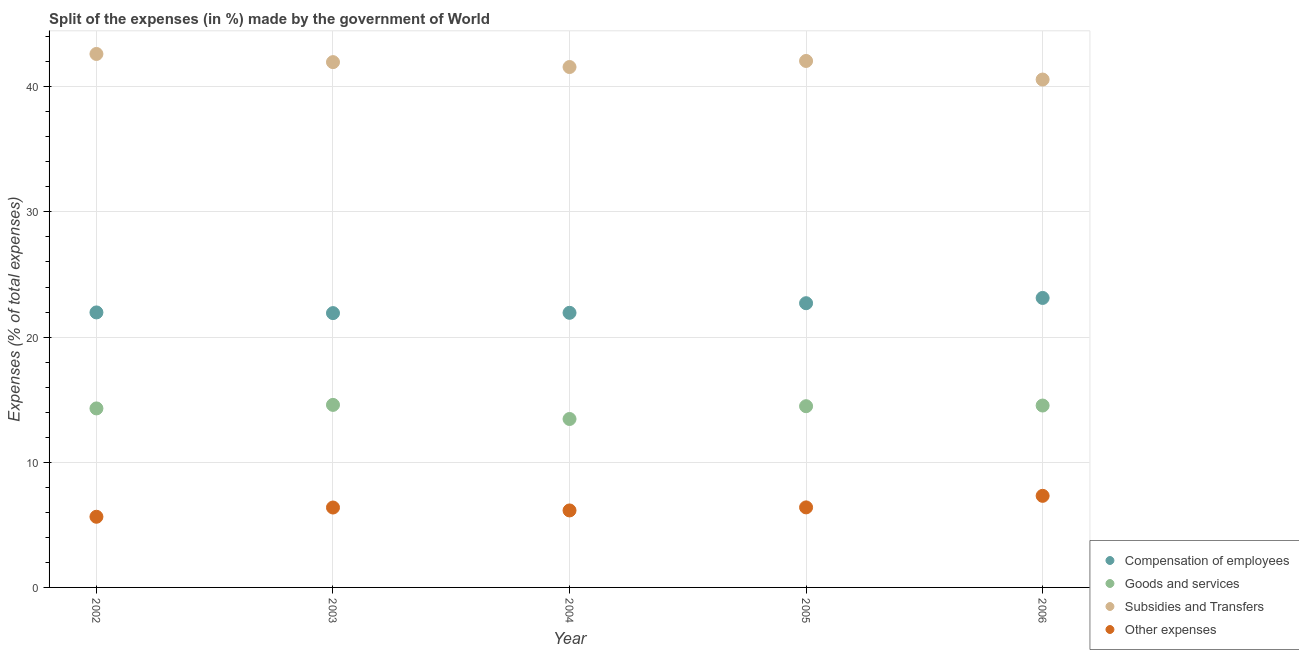How many different coloured dotlines are there?
Your answer should be compact. 4. What is the percentage of amount spent on other expenses in 2002?
Make the answer very short. 5.65. Across all years, what is the maximum percentage of amount spent on compensation of employees?
Your response must be concise. 23.13. Across all years, what is the minimum percentage of amount spent on subsidies?
Provide a short and direct response. 40.58. In which year was the percentage of amount spent on goods and services maximum?
Make the answer very short. 2003. In which year was the percentage of amount spent on other expenses minimum?
Your answer should be very brief. 2002. What is the total percentage of amount spent on goods and services in the graph?
Your answer should be compact. 71.35. What is the difference between the percentage of amount spent on goods and services in 2002 and that in 2004?
Ensure brevity in your answer.  0.84. What is the difference between the percentage of amount spent on compensation of employees in 2006 and the percentage of amount spent on goods and services in 2004?
Provide a short and direct response. 9.67. What is the average percentage of amount spent on compensation of employees per year?
Keep it short and to the point. 22.33. In the year 2006, what is the difference between the percentage of amount spent on compensation of employees and percentage of amount spent on goods and services?
Keep it short and to the point. 8.6. In how many years, is the percentage of amount spent on goods and services greater than 16 %?
Your answer should be very brief. 0. What is the ratio of the percentage of amount spent on compensation of employees in 2002 to that in 2005?
Ensure brevity in your answer.  0.97. Is the difference between the percentage of amount spent on other expenses in 2003 and 2006 greater than the difference between the percentage of amount spent on goods and services in 2003 and 2006?
Your response must be concise. No. What is the difference between the highest and the second highest percentage of amount spent on compensation of employees?
Give a very brief answer. 0.42. What is the difference between the highest and the lowest percentage of amount spent on other expenses?
Your answer should be very brief. 1.67. In how many years, is the percentage of amount spent on compensation of employees greater than the average percentage of amount spent on compensation of employees taken over all years?
Offer a very short reply. 2. Is the sum of the percentage of amount spent on subsidies in 2005 and 2006 greater than the maximum percentage of amount spent on other expenses across all years?
Offer a terse response. Yes. Is it the case that in every year, the sum of the percentage of amount spent on compensation of employees and percentage of amount spent on goods and services is greater than the percentage of amount spent on subsidies?
Offer a terse response. No. Is the percentage of amount spent on other expenses strictly greater than the percentage of amount spent on compensation of employees over the years?
Provide a succinct answer. No. Is the percentage of amount spent on goods and services strictly less than the percentage of amount spent on other expenses over the years?
Your response must be concise. No. How many dotlines are there?
Offer a terse response. 4. How many years are there in the graph?
Ensure brevity in your answer.  5. Are the values on the major ticks of Y-axis written in scientific E-notation?
Offer a very short reply. No. How many legend labels are there?
Offer a very short reply. 4. What is the title of the graph?
Provide a succinct answer. Split of the expenses (in %) made by the government of World. Does "Finland" appear as one of the legend labels in the graph?
Your answer should be compact. No. What is the label or title of the X-axis?
Your response must be concise. Year. What is the label or title of the Y-axis?
Keep it short and to the point. Expenses (% of total expenses). What is the Expenses (% of total expenses) of Compensation of employees in 2002?
Ensure brevity in your answer.  21.97. What is the Expenses (% of total expenses) in Goods and services in 2002?
Ensure brevity in your answer.  14.3. What is the Expenses (% of total expenses) of Subsidies and Transfers in 2002?
Your answer should be very brief. 42.62. What is the Expenses (% of total expenses) in Other expenses in 2002?
Your response must be concise. 5.65. What is the Expenses (% of total expenses) of Compensation of employees in 2003?
Give a very brief answer. 21.92. What is the Expenses (% of total expenses) in Goods and services in 2003?
Your answer should be very brief. 14.58. What is the Expenses (% of total expenses) of Subsidies and Transfers in 2003?
Offer a very short reply. 41.97. What is the Expenses (% of total expenses) of Other expenses in 2003?
Ensure brevity in your answer.  6.38. What is the Expenses (% of total expenses) of Compensation of employees in 2004?
Make the answer very short. 21.94. What is the Expenses (% of total expenses) in Goods and services in 2004?
Ensure brevity in your answer.  13.46. What is the Expenses (% of total expenses) of Subsidies and Transfers in 2004?
Give a very brief answer. 41.58. What is the Expenses (% of total expenses) of Other expenses in 2004?
Provide a short and direct response. 6.15. What is the Expenses (% of total expenses) of Compensation of employees in 2005?
Offer a terse response. 22.71. What is the Expenses (% of total expenses) of Goods and services in 2005?
Make the answer very short. 14.48. What is the Expenses (% of total expenses) in Subsidies and Transfers in 2005?
Your answer should be compact. 42.06. What is the Expenses (% of total expenses) of Other expenses in 2005?
Keep it short and to the point. 6.39. What is the Expenses (% of total expenses) of Compensation of employees in 2006?
Make the answer very short. 23.13. What is the Expenses (% of total expenses) of Goods and services in 2006?
Ensure brevity in your answer.  14.53. What is the Expenses (% of total expenses) of Subsidies and Transfers in 2006?
Offer a very short reply. 40.58. What is the Expenses (% of total expenses) of Other expenses in 2006?
Offer a terse response. 7.32. Across all years, what is the maximum Expenses (% of total expenses) of Compensation of employees?
Provide a succinct answer. 23.13. Across all years, what is the maximum Expenses (% of total expenses) of Goods and services?
Make the answer very short. 14.58. Across all years, what is the maximum Expenses (% of total expenses) in Subsidies and Transfers?
Your response must be concise. 42.62. Across all years, what is the maximum Expenses (% of total expenses) of Other expenses?
Make the answer very short. 7.32. Across all years, what is the minimum Expenses (% of total expenses) in Compensation of employees?
Provide a short and direct response. 21.92. Across all years, what is the minimum Expenses (% of total expenses) of Goods and services?
Provide a short and direct response. 13.46. Across all years, what is the minimum Expenses (% of total expenses) in Subsidies and Transfers?
Keep it short and to the point. 40.58. Across all years, what is the minimum Expenses (% of total expenses) of Other expenses?
Provide a succinct answer. 5.65. What is the total Expenses (% of total expenses) of Compensation of employees in the graph?
Keep it short and to the point. 111.66. What is the total Expenses (% of total expenses) of Goods and services in the graph?
Offer a terse response. 71.35. What is the total Expenses (% of total expenses) of Subsidies and Transfers in the graph?
Keep it short and to the point. 208.8. What is the total Expenses (% of total expenses) of Other expenses in the graph?
Provide a short and direct response. 31.89. What is the difference between the Expenses (% of total expenses) of Compensation of employees in 2002 and that in 2003?
Keep it short and to the point. 0.06. What is the difference between the Expenses (% of total expenses) of Goods and services in 2002 and that in 2003?
Ensure brevity in your answer.  -0.28. What is the difference between the Expenses (% of total expenses) of Subsidies and Transfers in 2002 and that in 2003?
Provide a succinct answer. 0.65. What is the difference between the Expenses (% of total expenses) of Other expenses in 2002 and that in 2003?
Keep it short and to the point. -0.74. What is the difference between the Expenses (% of total expenses) in Compensation of employees in 2002 and that in 2004?
Offer a very short reply. 0.03. What is the difference between the Expenses (% of total expenses) of Goods and services in 2002 and that in 2004?
Provide a short and direct response. 0.84. What is the difference between the Expenses (% of total expenses) in Subsidies and Transfers in 2002 and that in 2004?
Your answer should be very brief. 1.04. What is the difference between the Expenses (% of total expenses) of Other expenses in 2002 and that in 2004?
Offer a very short reply. -0.51. What is the difference between the Expenses (% of total expenses) in Compensation of employees in 2002 and that in 2005?
Provide a short and direct response. -0.74. What is the difference between the Expenses (% of total expenses) in Goods and services in 2002 and that in 2005?
Offer a very short reply. -0.18. What is the difference between the Expenses (% of total expenses) of Subsidies and Transfers in 2002 and that in 2005?
Offer a very short reply. 0.56. What is the difference between the Expenses (% of total expenses) in Other expenses in 2002 and that in 2005?
Keep it short and to the point. -0.75. What is the difference between the Expenses (% of total expenses) of Compensation of employees in 2002 and that in 2006?
Your response must be concise. -1.16. What is the difference between the Expenses (% of total expenses) in Goods and services in 2002 and that in 2006?
Your response must be concise. -0.23. What is the difference between the Expenses (% of total expenses) in Subsidies and Transfers in 2002 and that in 2006?
Keep it short and to the point. 2.04. What is the difference between the Expenses (% of total expenses) of Other expenses in 2002 and that in 2006?
Provide a short and direct response. -1.67. What is the difference between the Expenses (% of total expenses) in Compensation of employees in 2003 and that in 2004?
Ensure brevity in your answer.  -0.02. What is the difference between the Expenses (% of total expenses) of Goods and services in 2003 and that in 2004?
Your answer should be very brief. 1.13. What is the difference between the Expenses (% of total expenses) in Subsidies and Transfers in 2003 and that in 2004?
Keep it short and to the point. 0.39. What is the difference between the Expenses (% of total expenses) in Other expenses in 2003 and that in 2004?
Your answer should be very brief. 0.23. What is the difference between the Expenses (% of total expenses) of Compensation of employees in 2003 and that in 2005?
Offer a terse response. -0.79. What is the difference between the Expenses (% of total expenses) in Goods and services in 2003 and that in 2005?
Provide a short and direct response. 0.1. What is the difference between the Expenses (% of total expenses) of Subsidies and Transfers in 2003 and that in 2005?
Give a very brief answer. -0.09. What is the difference between the Expenses (% of total expenses) of Other expenses in 2003 and that in 2005?
Provide a succinct answer. -0.01. What is the difference between the Expenses (% of total expenses) of Compensation of employees in 2003 and that in 2006?
Provide a short and direct response. -1.21. What is the difference between the Expenses (% of total expenses) in Goods and services in 2003 and that in 2006?
Your answer should be very brief. 0.05. What is the difference between the Expenses (% of total expenses) of Subsidies and Transfers in 2003 and that in 2006?
Provide a short and direct response. 1.39. What is the difference between the Expenses (% of total expenses) of Other expenses in 2003 and that in 2006?
Offer a very short reply. -0.93. What is the difference between the Expenses (% of total expenses) in Compensation of employees in 2004 and that in 2005?
Offer a terse response. -0.77. What is the difference between the Expenses (% of total expenses) of Goods and services in 2004 and that in 2005?
Ensure brevity in your answer.  -1.02. What is the difference between the Expenses (% of total expenses) in Subsidies and Transfers in 2004 and that in 2005?
Provide a short and direct response. -0.48. What is the difference between the Expenses (% of total expenses) in Other expenses in 2004 and that in 2005?
Your answer should be very brief. -0.24. What is the difference between the Expenses (% of total expenses) in Compensation of employees in 2004 and that in 2006?
Offer a terse response. -1.19. What is the difference between the Expenses (% of total expenses) in Goods and services in 2004 and that in 2006?
Offer a very short reply. -1.07. What is the difference between the Expenses (% of total expenses) of Other expenses in 2004 and that in 2006?
Offer a very short reply. -1.17. What is the difference between the Expenses (% of total expenses) of Compensation of employees in 2005 and that in 2006?
Provide a short and direct response. -0.42. What is the difference between the Expenses (% of total expenses) of Goods and services in 2005 and that in 2006?
Make the answer very short. -0.05. What is the difference between the Expenses (% of total expenses) of Subsidies and Transfers in 2005 and that in 2006?
Keep it short and to the point. 1.48. What is the difference between the Expenses (% of total expenses) of Other expenses in 2005 and that in 2006?
Make the answer very short. -0.92. What is the difference between the Expenses (% of total expenses) of Compensation of employees in 2002 and the Expenses (% of total expenses) of Goods and services in 2003?
Offer a very short reply. 7.39. What is the difference between the Expenses (% of total expenses) in Compensation of employees in 2002 and the Expenses (% of total expenses) in Subsidies and Transfers in 2003?
Give a very brief answer. -20. What is the difference between the Expenses (% of total expenses) of Compensation of employees in 2002 and the Expenses (% of total expenses) of Other expenses in 2003?
Provide a succinct answer. 15.59. What is the difference between the Expenses (% of total expenses) of Goods and services in 2002 and the Expenses (% of total expenses) of Subsidies and Transfers in 2003?
Keep it short and to the point. -27.67. What is the difference between the Expenses (% of total expenses) of Goods and services in 2002 and the Expenses (% of total expenses) of Other expenses in 2003?
Your answer should be very brief. 7.92. What is the difference between the Expenses (% of total expenses) in Subsidies and Transfers in 2002 and the Expenses (% of total expenses) in Other expenses in 2003?
Keep it short and to the point. 36.24. What is the difference between the Expenses (% of total expenses) of Compensation of employees in 2002 and the Expenses (% of total expenses) of Goods and services in 2004?
Offer a terse response. 8.51. What is the difference between the Expenses (% of total expenses) in Compensation of employees in 2002 and the Expenses (% of total expenses) in Subsidies and Transfers in 2004?
Provide a short and direct response. -19.61. What is the difference between the Expenses (% of total expenses) of Compensation of employees in 2002 and the Expenses (% of total expenses) of Other expenses in 2004?
Provide a short and direct response. 15.82. What is the difference between the Expenses (% of total expenses) in Goods and services in 2002 and the Expenses (% of total expenses) in Subsidies and Transfers in 2004?
Your response must be concise. -27.28. What is the difference between the Expenses (% of total expenses) in Goods and services in 2002 and the Expenses (% of total expenses) in Other expenses in 2004?
Your response must be concise. 8.15. What is the difference between the Expenses (% of total expenses) of Subsidies and Transfers in 2002 and the Expenses (% of total expenses) of Other expenses in 2004?
Provide a short and direct response. 36.47. What is the difference between the Expenses (% of total expenses) in Compensation of employees in 2002 and the Expenses (% of total expenses) in Goods and services in 2005?
Your answer should be compact. 7.49. What is the difference between the Expenses (% of total expenses) of Compensation of employees in 2002 and the Expenses (% of total expenses) of Subsidies and Transfers in 2005?
Your answer should be very brief. -20.09. What is the difference between the Expenses (% of total expenses) in Compensation of employees in 2002 and the Expenses (% of total expenses) in Other expenses in 2005?
Make the answer very short. 15.58. What is the difference between the Expenses (% of total expenses) of Goods and services in 2002 and the Expenses (% of total expenses) of Subsidies and Transfers in 2005?
Your answer should be very brief. -27.76. What is the difference between the Expenses (% of total expenses) of Goods and services in 2002 and the Expenses (% of total expenses) of Other expenses in 2005?
Make the answer very short. 7.91. What is the difference between the Expenses (% of total expenses) in Subsidies and Transfers in 2002 and the Expenses (% of total expenses) in Other expenses in 2005?
Make the answer very short. 36.23. What is the difference between the Expenses (% of total expenses) of Compensation of employees in 2002 and the Expenses (% of total expenses) of Goods and services in 2006?
Make the answer very short. 7.44. What is the difference between the Expenses (% of total expenses) in Compensation of employees in 2002 and the Expenses (% of total expenses) in Subsidies and Transfers in 2006?
Your answer should be compact. -18.61. What is the difference between the Expenses (% of total expenses) in Compensation of employees in 2002 and the Expenses (% of total expenses) in Other expenses in 2006?
Provide a succinct answer. 14.65. What is the difference between the Expenses (% of total expenses) in Goods and services in 2002 and the Expenses (% of total expenses) in Subsidies and Transfers in 2006?
Offer a terse response. -26.28. What is the difference between the Expenses (% of total expenses) of Goods and services in 2002 and the Expenses (% of total expenses) of Other expenses in 2006?
Provide a succinct answer. 6.98. What is the difference between the Expenses (% of total expenses) of Subsidies and Transfers in 2002 and the Expenses (% of total expenses) of Other expenses in 2006?
Provide a succinct answer. 35.3. What is the difference between the Expenses (% of total expenses) in Compensation of employees in 2003 and the Expenses (% of total expenses) in Goods and services in 2004?
Keep it short and to the point. 8.46. What is the difference between the Expenses (% of total expenses) of Compensation of employees in 2003 and the Expenses (% of total expenses) of Subsidies and Transfers in 2004?
Make the answer very short. -19.66. What is the difference between the Expenses (% of total expenses) of Compensation of employees in 2003 and the Expenses (% of total expenses) of Other expenses in 2004?
Provide a succinct answer. 15.77. What is the difference between the Expenses (% of total expenses) of Goods and services in 2003 and the Expenses (% of total expenses) of Subsidies and Transfers in 2004?
Provide a succinct answer. -26.99. What is the difference between the Expenses (% of total expenses) of Goods and services in 2003 and the Expenses (% of total expenses) of Other expenses in 2004?
Ensure brevity in your answer.  8.43. What is the difference between the Expenses (% of total expenses) of Subsidies and Transfers in 2003 and the Expenses (% of total expenses) of Other expenses in 2004?
Make the answer very short. 35.82. What is the difference between the Expenses (% of total expenses) in Compensation of employees in 2003 and the Expenses (% of total expenses) in Goods and services in 2005?
Make the answer very short. 7.44. What is the difference between the Expenses (% of total expenses) in Compensation of employees in 2003 and the Expenses (% of total expenses) in Subsidies and Transfers in 2005?
Ensure brevity in your answer.  -20.15. What is the difference between the Expenses (% of total expenses) in Compensation of employees in 2003 and the Expenses (% of total expenses) in Other expenses in 2005?
Ensure brevity in your answer.  15.52. What is the difference between the Expenses (% of total expenses) in Goods and services in 2003 and the Expenses (% of total expenses) in Subsidies and Transfers in 2005?
Keep it short and to the point. -27.48. What is the difference between the Expenses (% of total expenses) of Goods and services in 2003 and the Expenses (% of total expenses) of Other expenses in 2005?
Your response must be concise. 8.19. What is the difference between the Expenses (% of total expenses) of Subsidies and Transfers in 2003 and the Expenses (% of total expenses) of Other expenses in 2005?
Keep it short and to the point. 35.57. What is the difference between the Expenses (% of total expenses) of Compensation of employees in 2003 and the Expenses (% of total expenses) of Goods and services in 2006?
Provide a short and direct response. 7.38. What is the difference between the Expenses (% of total expenses) of Compensation of employees in 2003 and the Expenses (% of total expenses) of Subsidies and Transfers in 2006?
Offer a very short reply. -18.66. What is the difference between the Expenses (% of total expenses) in Compensation of employees in 2003 and the Expenses (% of total expenses) in Other expenses in 2006?
Keep it short and to the point. 14.6. What is the difference between the Expenses (% of total expenses) in Goods and services in 2003 and the Expenses (% of total expenses) in Subsidies and Transfers in 2006?
Ensure brevity in your answer.  -25.99. What is the difference between the Expenses (% of total expenses) in Goods and services in 2003 and the Expenses (% of total expenses) in Other expenses in 2006?
Your answer should be very brief. 7.27. What is the difference between the Expenses (% of total expenses) of Subsidies and Transfers in 2003 and the Expenses (% of total expenses) of Other expenses in 2006?
Your response must be concise. 34.65. What is the difference between the Expenses (% of total expenses) in Compensation of employees in 2004 and the Expenses (% of total expenses) in Goods and services in 2005?
Offer a very short reply. 7.46. What is the difference between the Expenses (% of total expenses) in Compensation of employees in 2004 and the Expenses (% of total expenses) in Subsidies and Transfers in 2005?
Your response must be concise. -20.12. What is the difference between the Expenses (% of total expenses) of Compensation of employees in 2004 and the Expenses (% of total expenses) of Other expenses in 2005?
Your answer should be compact. 15.55. What is the difference between the Expenses (% of total expenses) in Goods and services in 2004 and the Expenses (% of total expenses) in Subsidies and Transfers in 2005?
Ensure brevity in your answer.  -28.6. What is the difference between the Expenses (% of total expenses) of Goods and services in 2004 and the Expenses (% of total expenses) of Other expenses in 2005?
Make the answer very short. 7.06. What is the difference between the Expenses (% of total expenses) in Subsidies and Transfers in 2004 and the Expenses (% of total expenses) in Other expenses in 2005?
Provide a short and direct response. 35.18. What is the difference between the Expenses (% of total expenses) of Compensation of employees in 2004 and the Expenses (% of total expenses) of Goods and services in 2006?
Keep it short and to the point. 7.41. What is the difference between the Expenses (% of total expenses) of Compensation of employees in 2004 and the Expenses (% of total expenses) of Subsidies and Transfers in 2006?
Your response must be concise. -18.64. What is the difference between the Expenses (% of total expenses) in Compensation of employees in 2004 and the Expenses (% of total expenses) in Other expenses in 2006?
Offer a very short reply. 14.62. What is the difference between the Expenses (% of total expenses) in Goods and services in 2004 and the Expenses (% of total expenses) in Subsidies and Transfers in 2006?
Keep it short and to the point. -27.12. What is the difference between the Expenses (% of total expenses) in Goods and services in 2004 and the Expenses (% of total expenses) in Other expenses in 2006?
Keep it short and to the point. 6.14. What is the difference between the Expenses (% of total expenses) of Subsidies and Transfers in 2004 and the Expenses (% of total expenses) of Other expenses in 2006?
Keep it short and to the point. 34.26. What is the difference between the Expenses (% of total expenses) in Compensation of employees in 2005 and the Expenses (% of total expenses) in Goods and services in 2006?
Keep it short and to the point. 8.18. What is the difference between the Expenses (% of total expenses) of Compensation of employees in 2005 and the Expenses (% of total expenses) of Subsidies and Transfers in 2006?
Ensure brevity in your answer.  -17.87. What is the difference between the Expenses (% of total expenses) of Compensation of employees in 2005 and the Expenses (% of total expenses) of Other expenses in 2006?
Your answer should be very brief. 15.39. What is the difference between the Expenses (% of total expenses) of Goods and services in 2005 and the Expenses (% of total expenses) of Subsidies and Transfers in 2006?
Offer a terse response. -26.1. What is the difference between the Expenses (% of total expenses) of Goods and services in 2005 and the Expenses (% of total expenses) of Other expenses in 2006?
Ensure brevity in your answer.  7.16. What is the difference between the Expenses (% of total expenses) of Subsidies and Transfers in 2005 and the Expenses (% of total expenses) of Other expenses in 2006?
Make the answer very short. 34.74. What is the average Expenses (% of total expenses) of Compensation of employees per year?
Your response must be concise. 22.33. What is the average Expenses (% of total expenses) of Goods and services per year?
Offer a terse response. 14.27. What is the average Expenses (% of total expenses) of Subsidies and Transfers per year?
Make the answer very short. 41.76. What is the average Expenses (% of total expenses) in Other expenses per year?
Ensure brevity in your answer.  6.38. In the year 2002, what is the difference between the Expenses (% of total expenses) of Compensation of employees and Expenses (% of total expenses) of Goods and services?
Ensure brevity in your answer.  7.67. In the year 2002, what is the difference between the Expenses (% of total expenses) in Compensation of employees and Expenses (% of total expenses) in Subsidies and Transfers?
Offer a very short reply. -20.65. In the year 2002, what is the difference between the Expenses (% of total expenses) in Compensation of employees and Expenses (% of total expenses) in Other expenses?
Offer a terse response. 16.33. In the year 2002, what is the difference between the Expenses (% of total expenses) in Goods and services and Expenses (% of total expenses) in Subsidies and Transfers?
Offer a terse response. -28.32. In the year 2002, what is the difference between the Expenses (% of total expenses) of Goods and services and Expenses (% of total expenses) of Other expenses?
Offer a terse response. 8.66. In the year 2002, what is the difference between the Expenses (% of total expenses) of Subsidies and Transfers and Expenses (% of total expenses) of Other expenses?
Offer a terse response. 36.98. In the year 2003, what is the difference between the Expenses (% of total expenses) in Compensation of employees and Expenses (% of total expenses) in Goods and services?
Offer a terse response. 7.33. In the year 2003, what is the difference between the Expenses (% of total expenses) in Compensation of employees and Expenses (% of total expenses) in Subsidies and Transfers?
Keep it short and to the point. -20.05. In the year 2003, what is the difference between the Expenses (% of total expenses) in Compensation of employees and Expenses (% of total expenses) in Other expenses?
Provide a short and direct response. 15.53. In the year 2003, what is the difference between the Expenses (% of total expenses) of Goods and services and Expenses (% of total expenses) of Subsidies and Transfers?
Provide a succinct answer. -27.39. In the year 2003, what is the difference between the Expenses (% of total expenses) in Goods and services and Expenses (% of total expenses) in Other expenses?
Provide a succinct answer. 8.2. In the year 2003, what is the difference between the Expenses (% of total expenses) in Subsidies and Transfers and Expenses (% of total expenses) in Other expenses?
Offer a very short reply. 35.58. In the year 2004, what is the difference between the Expenses (% of total expenses) in Compensation of employees and Expenses (% of total expenses) in Goods and services?
Offer a very short reply. 8.48. In the year 2004, what is the difference between the Expenses (% of total expenses) of Compensation of employees and Expenses (% of total expenses) of Subsidies and Transfers?
Your answer should be compact. -19.64. In the year 2004, what is the difference between the Expenses (% of total expenses) of Compensation of employees and Expenses (% of total expenses) of Other expenses?
Offer a terse response. 15.79. In the year 2004, what is the difference between the Expenses (% of total expenses) in Goods and services and Expenses (% of total expenses) in Subsidies and Transfers?
Ensure brevity in your answer.  -28.12. In the year 2004, what is the difference between the Expenses (% of total expenses) in Goods and services and Expenses (% of total expenses) in Other expenses?
Give a very brief answer. 7.31. In the year 2004, what is the difference between the Expenses (% of total expenses) in Subsidies and Transfers and Expenses (% of total expenses) in Other expenses?
Your answer should be very brief. 35.43. In the year 2005, what is the difference between the Expenses (% of total expenses) in Compensation of employees and Expenses (% of total expenses) in Goods and services?
Provide a short and direct response. 8.23. In the year 2005, what is the difference between the Expenses (% of total expenses) in Compensation of employees and Expenses (% of total expenses) in Subsidies and Transfers?
Ensure brevity in your answer.  -19.35. In the year 2005, what is the difference between the Expenses (% of total expenses) of Compensation of employees and Expenses (% of total expenses) of Other expenses?
Make the answer very short. 16.31. In the year 2005, what is the difference between the Expenses (% of total expenses) in Goods and services and Expenses (% of total expenses) in Subsidies and Transfers?
Offer a very short reply. -27.58. In the year 2005, what is the difference between the Expenses (% of total expenses) of Goods and services and Expenses (% of total expenses) of Other expenses?
Offer a terse response. 8.08. In the year 2005, what is the difference between the Expenses (% of total expenses) of Subsidies and Transfers and Expenses (% of total expenses) of Other expenses?
Offer a very short reply. 35.67. In the year 2006, what is the difference between the Expenses (% of total expenses) of Compensation of employees and Expenses (% of total expenses) of Goods and services?
Make the answer very short. 8.6. In the year 2006, what is the difference between the Expenses (% of total expenses) in Compensation of employees and Expenses (% of total expenses) in Subsidies and Transfers?
Make the answer very short. -17.45. In the year 2006, what is the difference between the Expenses (% of total expenses) in Compensation of employees and Expenses (% of total expenses) in Other expenses?
Your answer should be very brief. 15.81. In the year 2006, what is the difference between the Expenses (% of total expenses) of Goods and services and Expenses (% of total expenses) of Subsidies and Transfers?
Keep it short and to the point. -26.05. In the year 2006, what is the difference between the Expenses (% of total expenses) of Goods and services and Expenses (% of total expenses) of Other expenses?
Provide a succinct answer. 7.21. In the year 2006, what is the difference between the Expenses (% of total expenses) of Subsidies and Transfers and Expenses (% of total expenses) of Other expenses?
Provide a short and direct response. 33.26. What is the ratio of the Expenses (% of total expenses) in Goods and services in 2002 to that in 2003?
Offer a very short reply. 0.98. What is the ratio of the Expenses (% of total expenses) in Subsidies and Transfers in 2002 to that in 2003?
Your answer should be compact. 1.02. What is the ratio of the Expenses (% of total expenses) in Other expenses in 2002 to that in 2003?
Your answer should be very brief. 0.88. What is the ratio of the Expenses (% of total expenses) in Goods and services in 2002 to that in 2004?
Your answer should be compact. 1.06. What is the ratio of the Expenses (% of total expenses) of Subsidies and Transfers in 2002 to that in 2004?
Your response must be concise. 1.03. What is the ratio of the Expenses (% of total expenses) of Other expenses in 2002 to that in 2004?
Make the answer very short. 0.92. What is the ratio of the Expenses (% of total expenses) of Compensation of employees in 2002 to that in 2005?
Your answer should be very brief. 0.97. What is the ratio of the Expenses (% of total expenses) of Subsidies and Transfers in 2002 to that in 2005?
Your response must be concise. 1.01. What is the ratio of the Expenses (% of total expenses) in Other expenses in 2002 to that in 2005?
Offer a terse response. 0.88. What is the ratio of the Expenses (% of total expenses) of Goods and services in 2002 to that in 2006?
Keep it short and to the point. 0.98. What is the ratio of the Expenses (% of total expenses) of Subsidies and Transfers in 2002 to that in 2006?
Offer a terse response. 1.05. What is the ratio of the Expenses (% of total expenses) of Other expenses in 2002 to that in 2006?
Provide a short and direct response. 0.77. What is the ratio of the Expenses (% of total expenses) of Goods and services in 2003 to that in 2004?
Give a very brief answer. 1.08. What is the ratio of the Expenses (% of total expenses) of Subsidies and Transfers in 2003 to that in 2004?
Your answer should be compact. 1.01. What is the ratio of the Expenses (% of total expenses) in Other expenses in 2003 to that in 2004?
Your response must be concise. 1.04. What is the ratio of the Expenses (% of total expenses) in Compensation of employees in 2003 to that in 2005?
Provide a short and direct response. 0.97. What is the ratio of the Expenses (% of total expenses) in Goods and services in 2003 to that in 2005?
Your answer should be compact. 1.01. What is the ratio of the Expenses (% of total expenses) of Other expenses in 2003 to that in 2005?
Your answer should be compact. 1. What is the ratio of the Expenses (% of total expenses) of Compensation of employees in 2003 to that in 2006?
Offer a terse response. 0.95. What is the ratio of the Expenses (% of total expenses) in Subsidies and Transfers in 2003 to that in 2006?
Provide a short and direct response. 1.03. What is the ratio of the Expenses (% of total expenses) in Other expenses in 2003 to that in 2006?
Provide a succinct answer. 0.87. What is the ratio of the Expenses (% of total expenses) in Compensation of employees in 2004 to that in 2005?
Give a very brief answer. 0.97. What is the ratio of the Expenses (% of total expenses) of Goods and services in 2004 to that in 2005?
Give a very brief answer. 0.93. What is the ratio of the Expenses (% of total expenses) of Other expenses in 2004 to that in 2005?
Your answer should be compact. 0.96. What is the ratio of the Expenses (% of total expenses) of Compensation of employees in 2004 to that in 2006?
Your response must be concise. 0.95. What is the ratio of the Expenses (% of total expenses) in Goods and services in 2004 to that in 2006?
Your answer should be very brief. 0.93. What is the ratio of the Expenses (% of total expenses) in Subsidies and Transfers in 2004 to that in 2006?
Give a very brief answer. 1.02. What is the ratio of the Expenses (% of total expenses) of Other expenses in 2004 to that in 2006?
Your response must be concise. 0.84. What is the ratio of the Expenses (% of total expenses) of Compensation of employees in 2005 to that in 2006?
Make the answer very short. 0.98. What is the ratio of the Expenses (% of total expenses) in Goods and services in 2005 to that in 2006?
Provide a succinct answer. 1. What is the ratio of the Expenses (% of total expenses) in Subsidies and Transfers in 2005 to that in 2006?
Keep it short and to the point. 1.04. What is the ratio of the Expenses (% of total expenses) in Other expenses in 2005 to that in 2006?
Make the answer very short. 0.87. What is the difference between the highest and the second highest Expenses (% of total expenses) in Compensation of employees?
Provide a short and direct response. 0.42. What is the difference between the highest and the second highest Expenses (% of total expenses) of Goods and services?
Provide a succinct answer. 0.05. What is the difference between the highest and the second highest Expenses (% of total expenses) of Subsidies and Transfers?
Your answer should be very brief. 0.56. What is the difference between the highest and the second highest Expenses (% of total expenses) of Other expenses?
Ensure brevity in your answer.  0.92. What is the difference between the highest and the lowest Expenses (% of total expenses) in Compensation of employees?
Provide a short and direct response. 1.21. What is the difference between the highest and the lowest Expenses (% of total expenses) of Goods and services?
Give a very brief answer. 1.13. What is the difference between the highest and the lowest Expenses (% of total expenses) of Subsidies and Transfers?
Ensure brevity in your answer.  2.04. What is the difference between the highest and the lowest Expenses (% of total expenses) of Other expenses?
Offer a terse response. 1.67. 